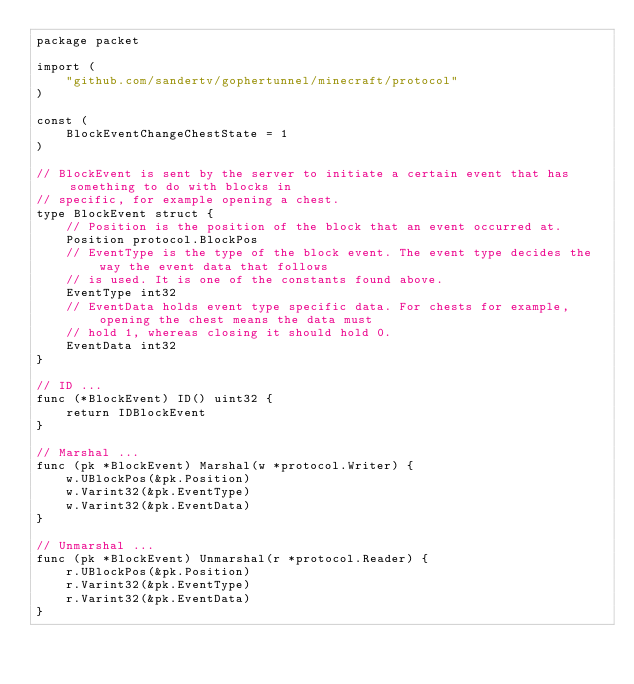Convert code to text. <code><loc_0><loc_0><loc_500><loc_500><_Go_>package packet

import (
	"github.com/sandertv/gophertunnel/minecraft/protocol"
)

const (
	BlockEventChangeChestState = 1
)

// BlockEvent is sent by the server to initiate a certain event that has something to do with blocks in
// specific, for example opening a chest.
type BlockEvent struct {
	// Position is the position of the block that an event occurred at.
	Position protocol.BlockPos
	// EventType is the type of the block event. The event type decides the way the event data that follows
	// is used. It is one of the constants found above.
	EventType int32
	// EventData holds event type specific data. For chests for example, opening the chest means the data must
	// hold 1, whereas closing it should hold 0.
	EventData int32
}

// ID ...
func (*BlockEvent) ID() uint32 {
	return IDBlockEvent
}

// Marshal ...
func (pk *BlockEvent) Marshal(w *protocol.Writer) {
	w.UBlockPos(&pk.Position)
	w.Varint32(&pk.EventType)
	w.Varint32(&pk.EventData)
}

// Unmarshal ...
func (pk *BlockEvent) Unmarshal(r *protocol.Reader) {
	r.UBlockPos(&pk.Position)
	r.Varint32(&pk.EventType)
	r.Varint32(&pk.EventData)
}
</code> 